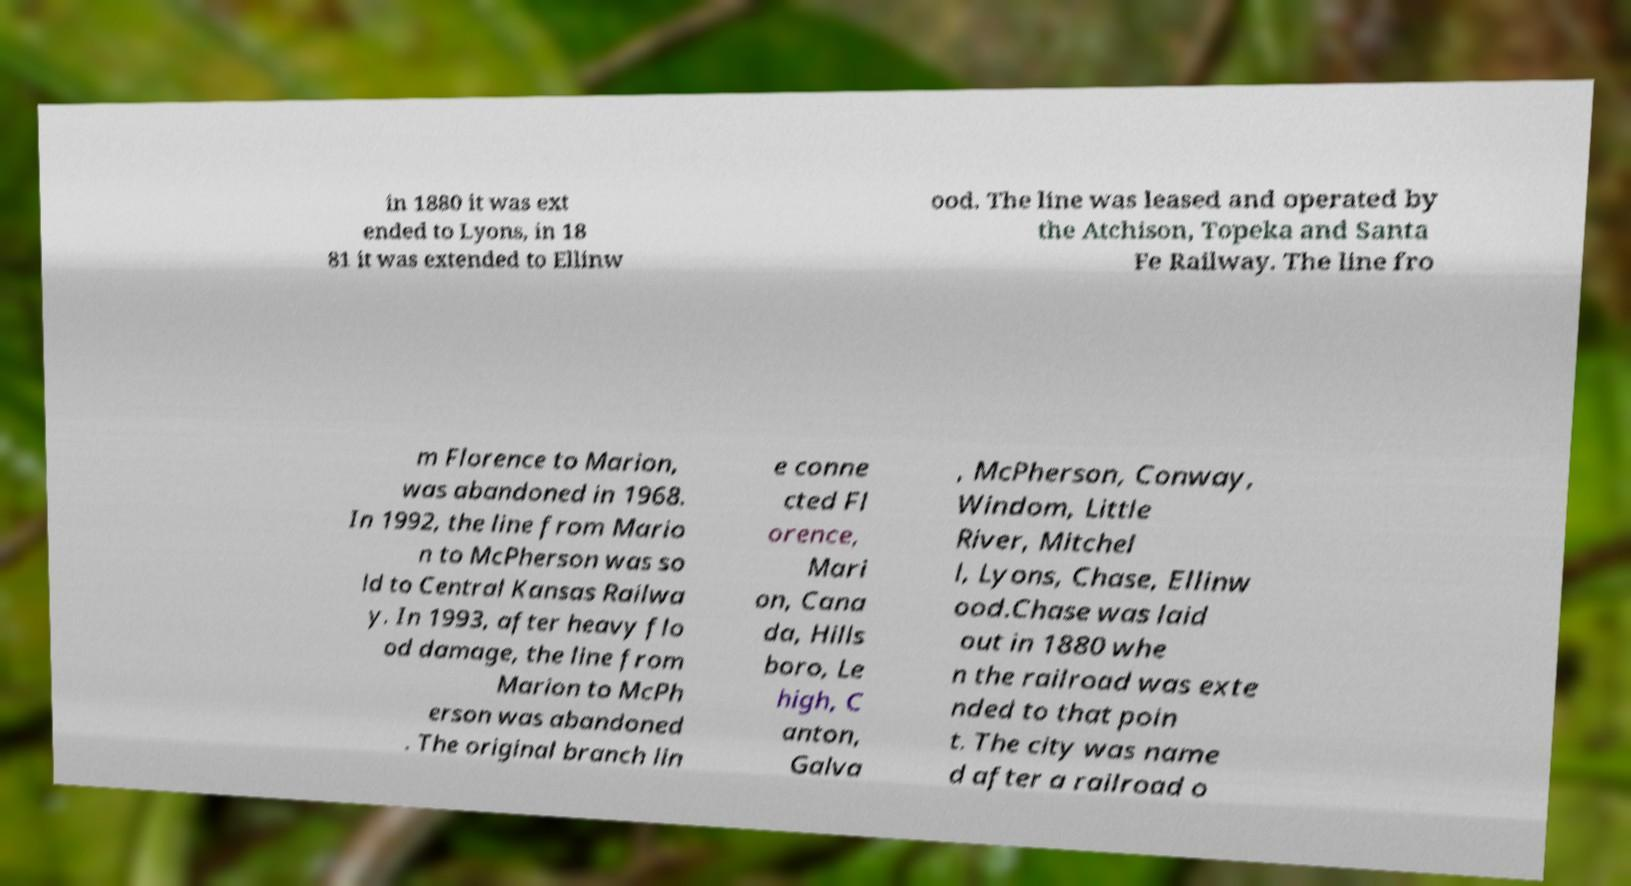There's text embedded in this image that I need extracted. Can you transcribe it verbatim? in 1880 it was ext ended to Lyons, in 18 81 it was extended to Ellinw ood. The line was leased and operated by the Atchison, Topeka and Santa Fe Railway. The line fro m Florence to Marion, was abandoned in 1968. In 1992, the line from Mario n to McPherson was so ld to Central Kansas Railwa y. In 1993, after heavy flo od damage, the line from Marion to McPh erson was abandoned . The original branch lin e conne cted Fl orence, Mari on, Cana da, Hills boro, Le high, C anton, Galva , McPherson, Conway, Windom, Little River, Mitchel l, Lyons, Chase, Ellinw ood.Chase was laid out in 1880 whe n the railroad was exte nded to that poin t. The city was name d after a railroad o 